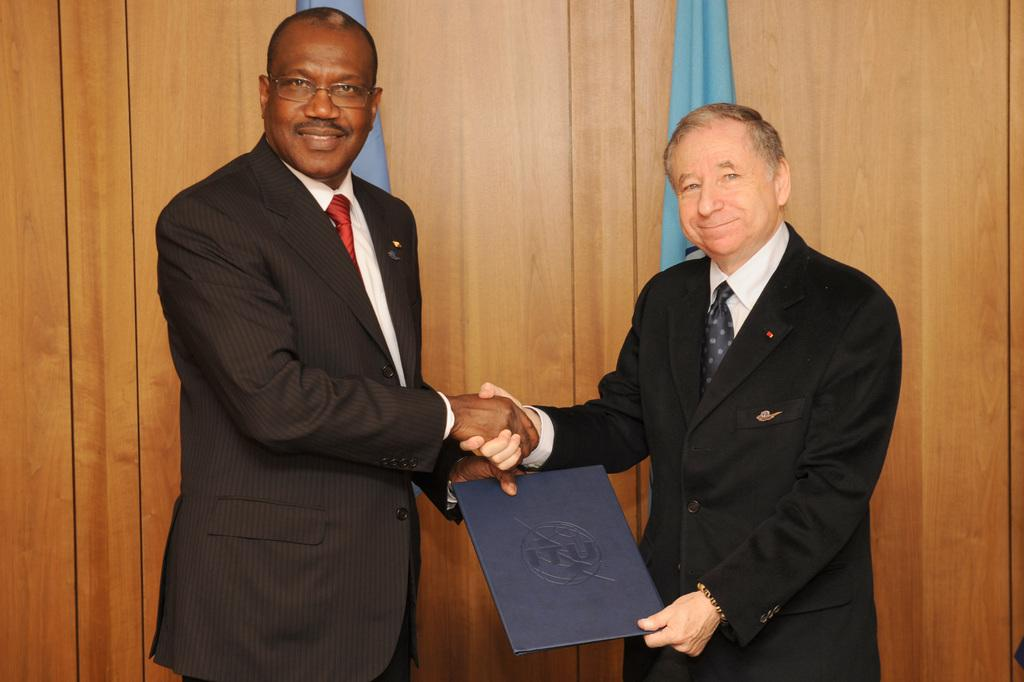How many people are in the image? There are two persons in the image. What are the persons doing in the image? The persons are standing on the floor. What is one of the persons holding in the image? One of the persons is holding a book in his hands. What can be seen in the background of the image? There are flags and a wall in the background of the image. What type of debt is being discussed in the image? There is no mention of debt in the image; it features two people standing and one holding a book. What type of polish is being applied to the wall in the image? There is no indication of any polish being applied to the wall in the image. --- Facts: 1. There is a car in the image. 2. The car is parked on the street. 3. There are trees on the side of the street. 4. The sky is visible in the image. 5. There is a traffic light near the car. Absurd Topics: parrot, dance, ocean Conversation: What is the main subject of the image? The main subject of the image is a car. Where is the car located in the image? The car is parked on the street. What can be seen on the side of the street in the image? There are trees on the side of the street. What is visible in the background of the image? The sky is visible in the image. What traffic control device is near the car in the image? There is a traffic light near the car in the image. Reasoning: Let's think step by step in order to produce the conversation. We start by identifying the main subject of the image, which is the car. Then, we describe the car's location, noting that it is parked on the street. Next, we mention the vegetation on the side of the street, which are trees. We then describe the background of the image, which includes the sky. Finally, we identify a traffic control device near the car, which is a traffic light. Absurd Question/Answer: Can you see a parrot dancing near the ocean in the image? There is no parrot or ocean present in the image; it features include a car, trees, and a traffic light. What type of dance is the parrot performing near the car in the image? There is no parrot present in the image, so it is not possible to determine what type of dance it might be performing. 